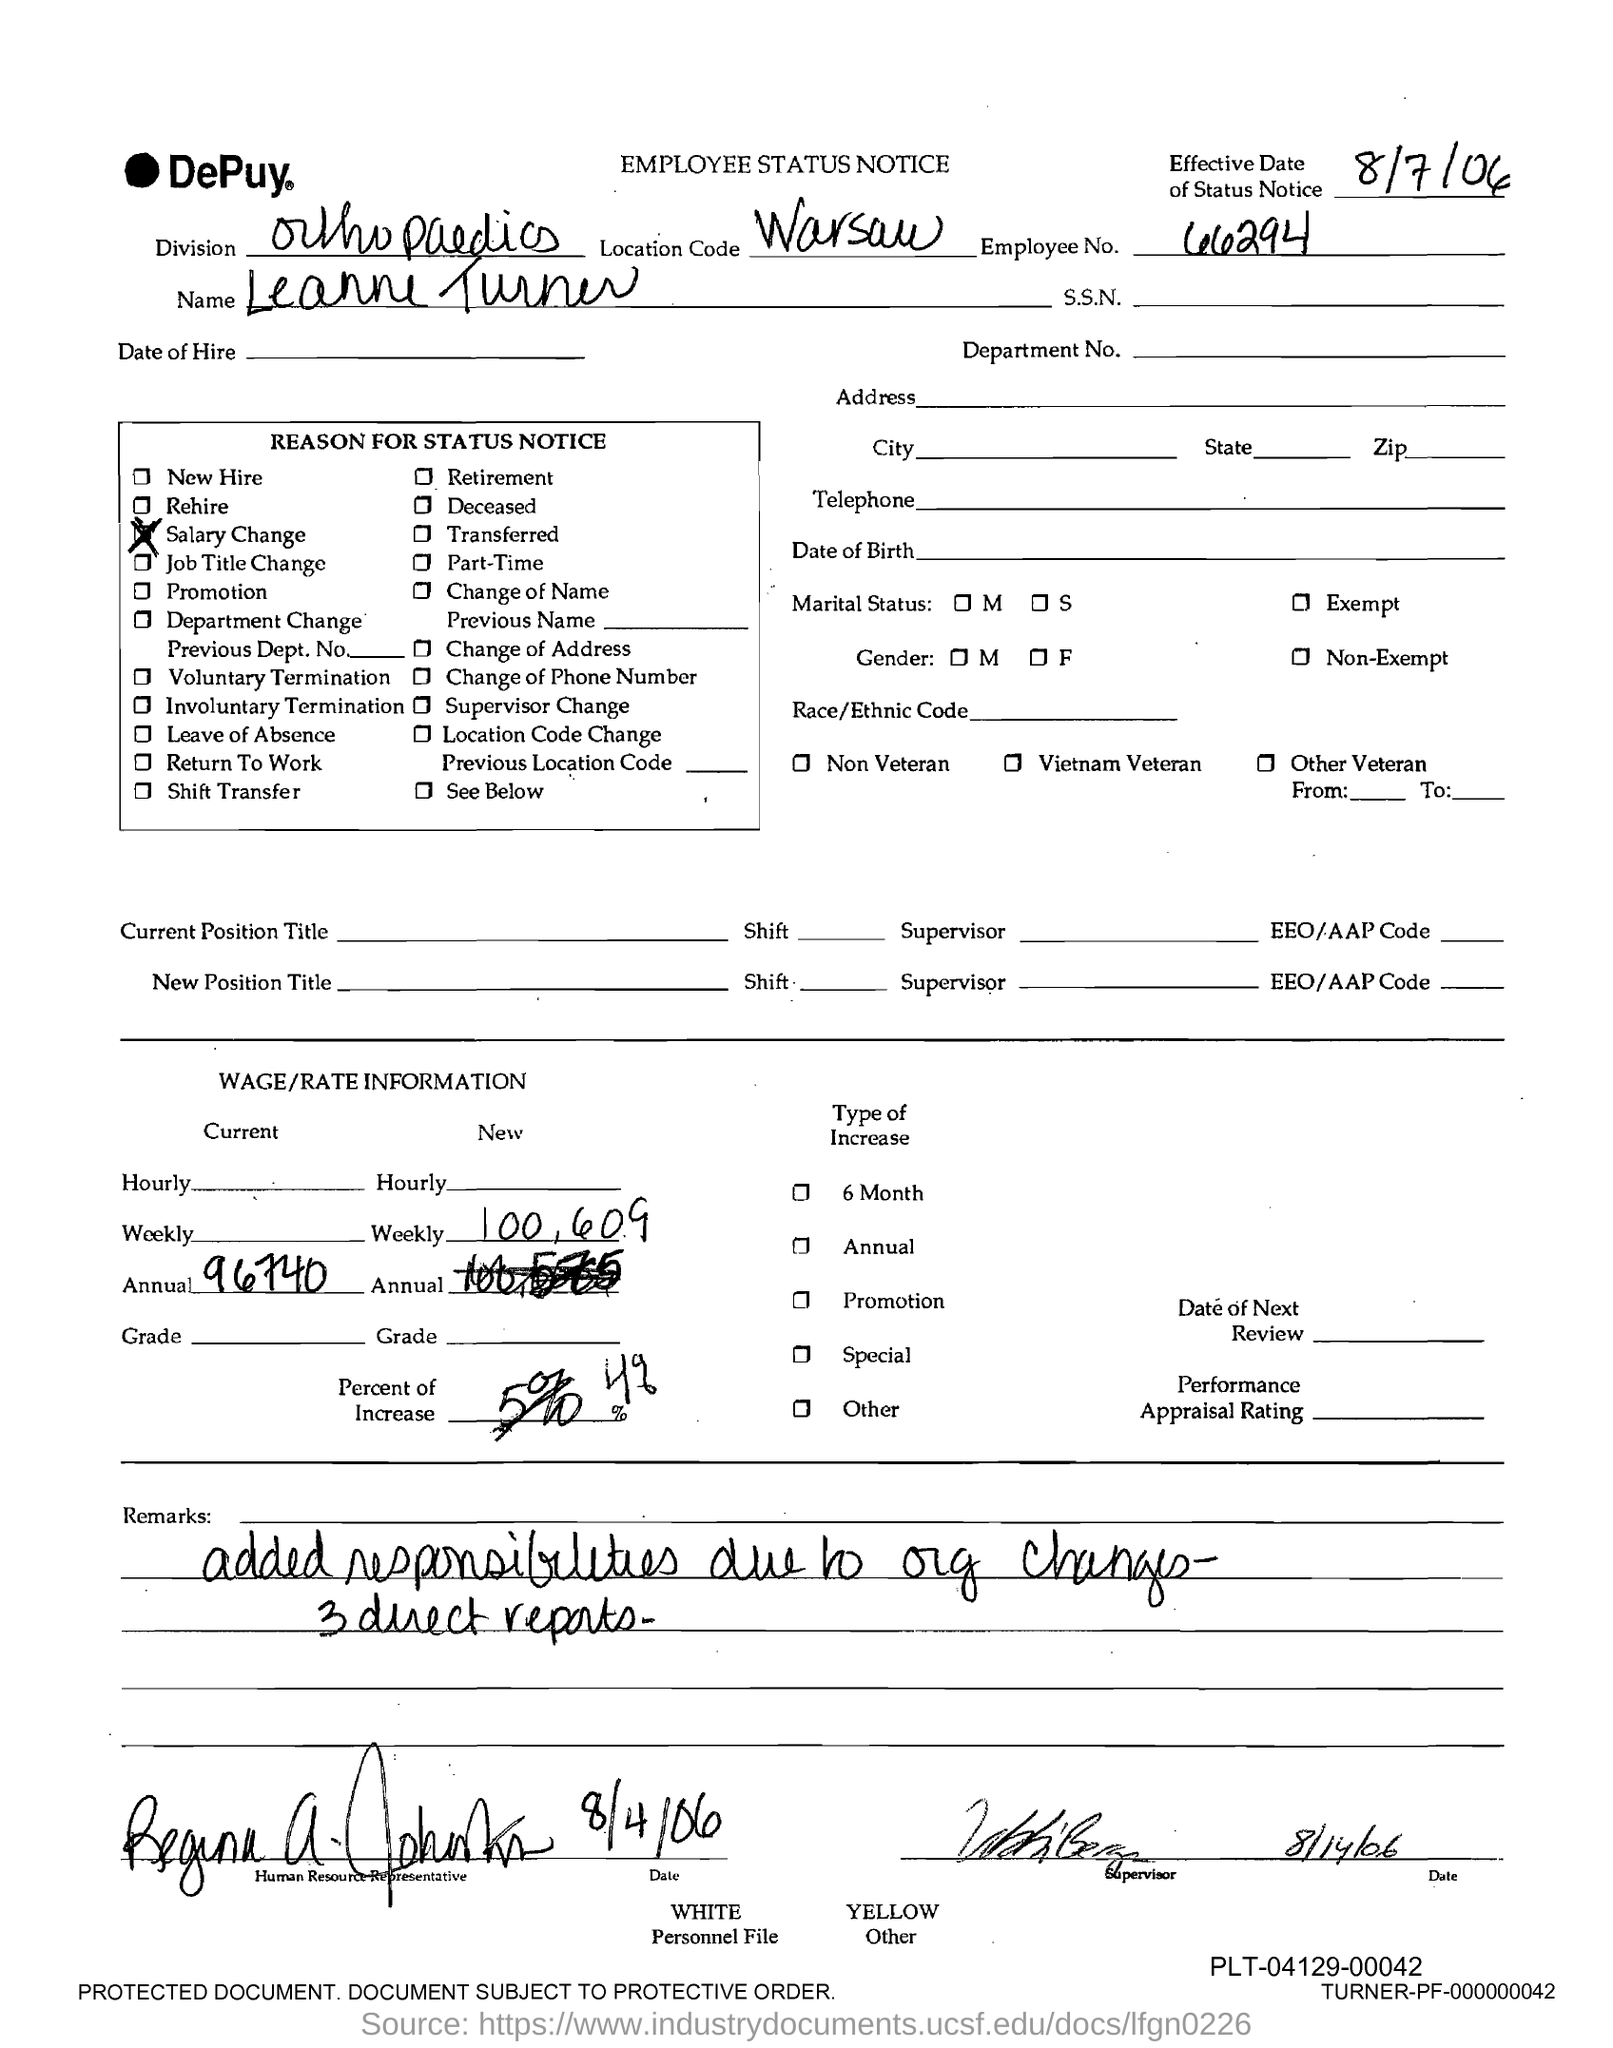Indicate a few pertinent items in this graphic. The location code given in the status notice is "Warsaw. This employee status notice is issued by Leanne Turner. The reason for the status notice is due to a salary change. The employee number mentioned in the status notice is 66294. Leanne Turner works in the orthopedic division. 